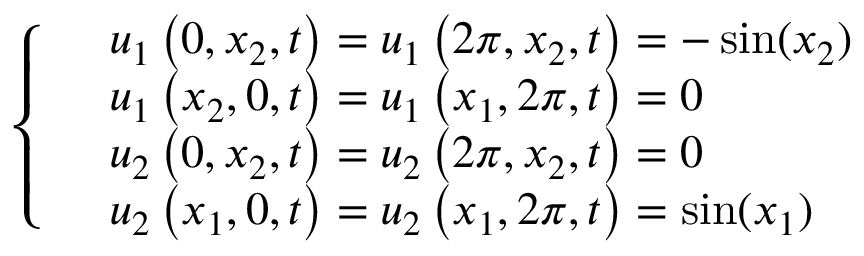<formula> <loc_0><loc_0><loc_500><loc_500>\left \{ \begin{array} { r l } & { u _ { 1 } \left ( 0 , { { x } _ { 2 } } , t \right ) = u _ { 1 } \left ( 2 \pi , { { x } _ { 2 } } , t \right ) = - \sin ( x _ { 2 } ) } \\ & { u _ { 1 } \left ( { { x } _ { 2 } } , 0 , t \right ) = u _ { 1 } \left ( { { x } _ { 1 } } , 2 \pi , t \right ) = 0 } \\ & { u _ { 2 } \left ( 0 , { { x } _ { 2 } } , t \right ) = u _ { 2 } \left ( 2 \pi , { { x } _ { 2 } } , t \right ) = 0 } \\ & { u _ { 2 } \left ( { { x } _ { 1 } } , 0 , t \right ) = u _ { 2 } \left ( { { x } _ { 1 } } , 2 \pi , t \right ) = \sin ( x _ { 1 } ) } \end{array}</formula> 